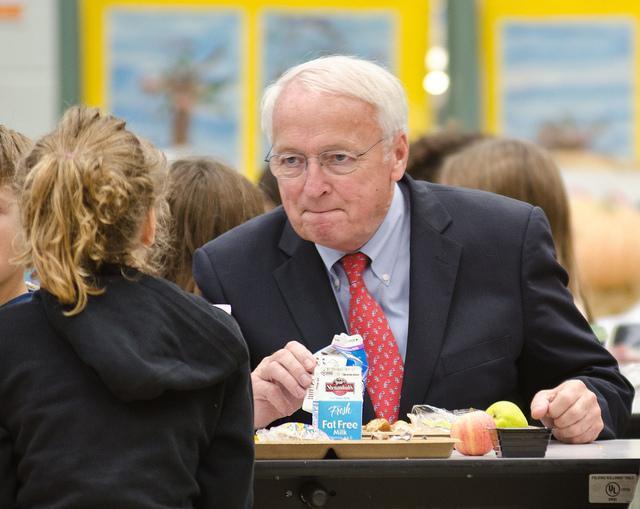How many people are in the picture?
Give a very brief answer. 6. 